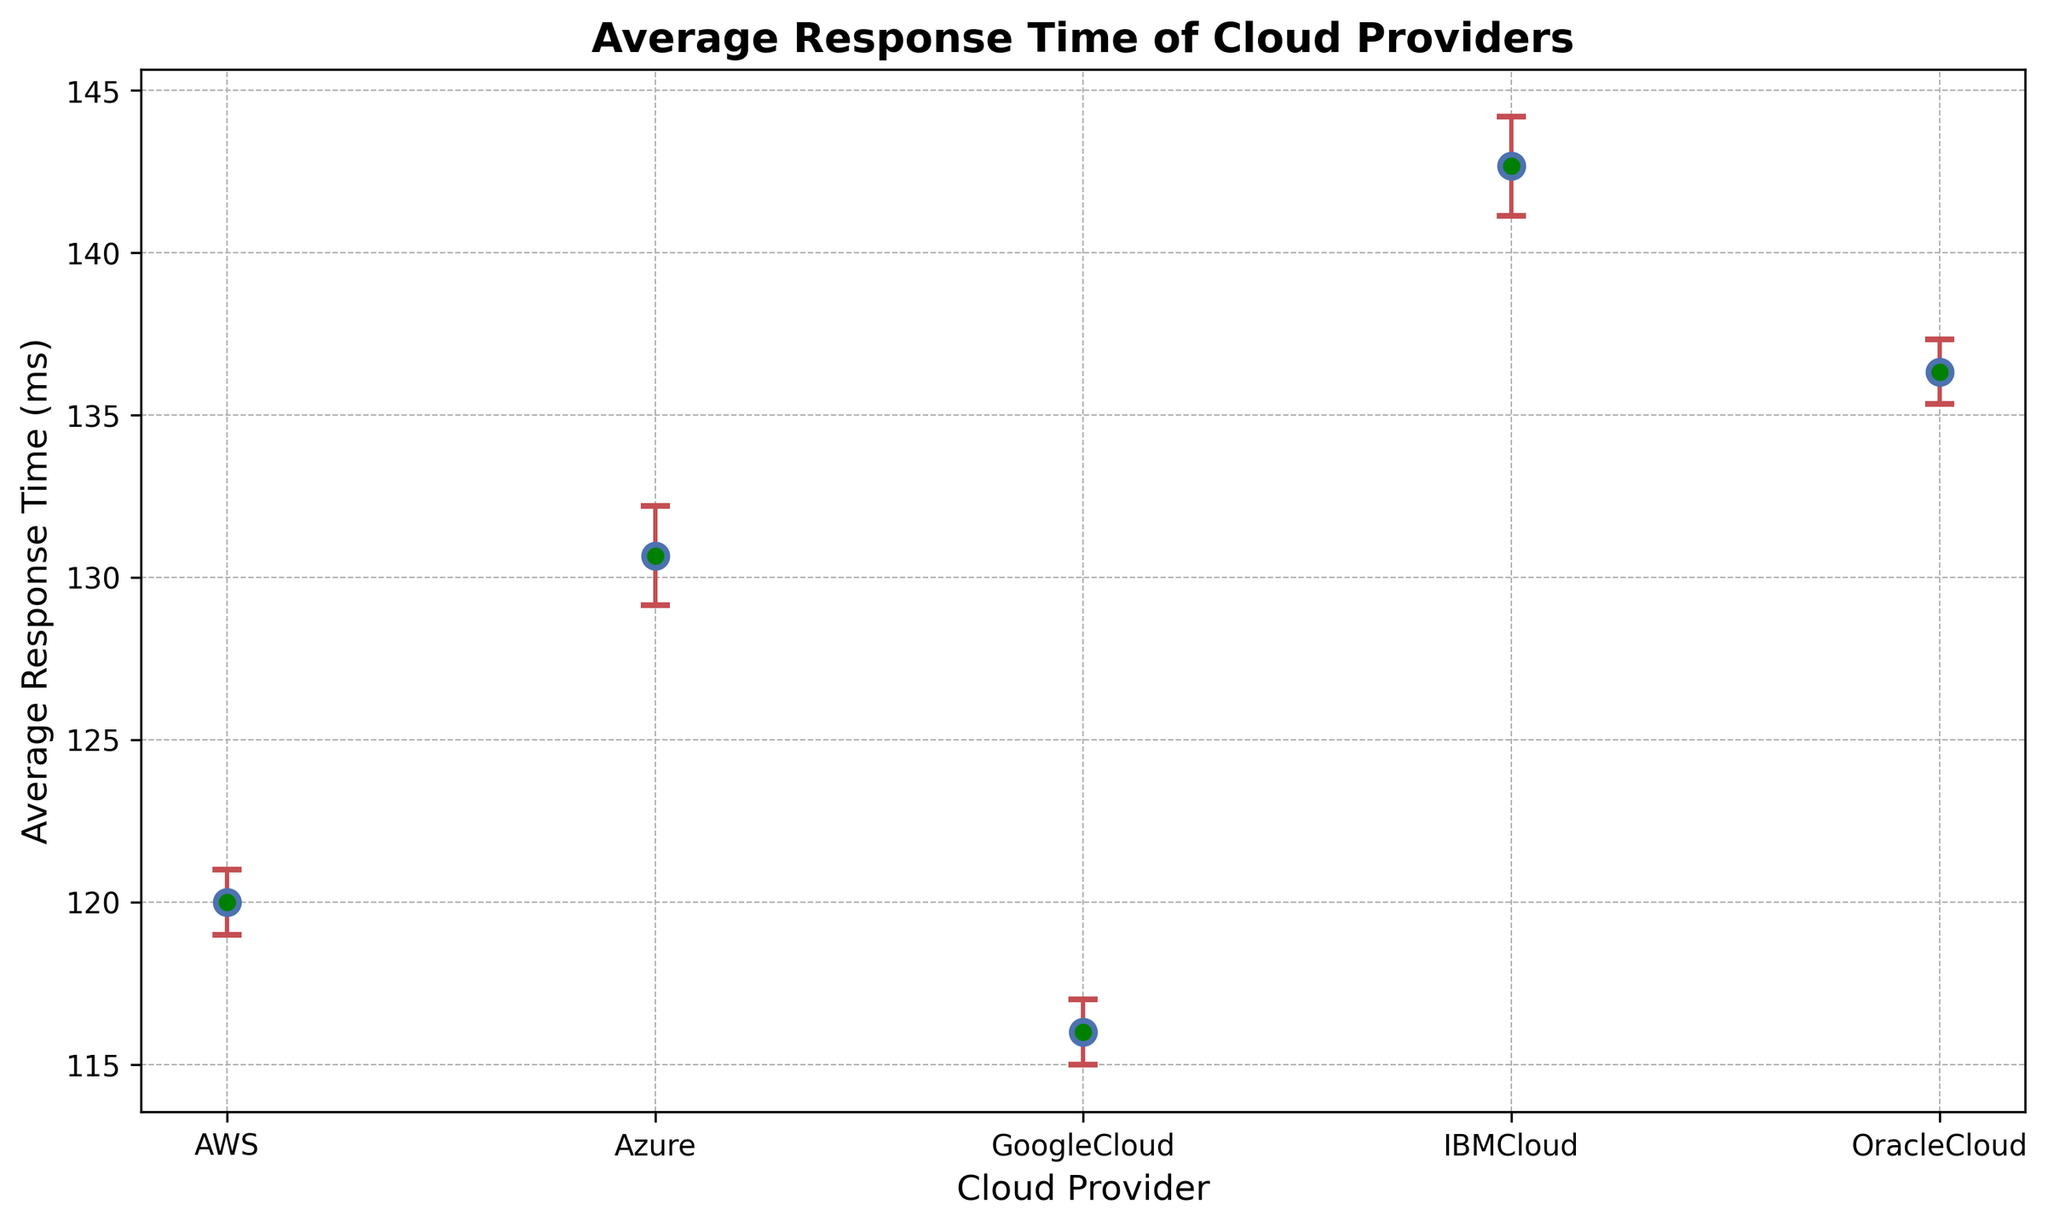What is the cloud provider with the highest average response time? By looking at the figure, you can see that the mean response time for each cloud provider is represented by a data point. The data point for IBMCloud is the highest on the y-axis, indicating the highest average response time.
Answer: IBMCloud Which cloud provider has the smallest average response time? By examining the plot, the data point for GoogleCloud is the lowest on the y-axis, indicating the smallest average response time.
Answer: GoogleCloud Which cloud providers' average response times overlap considering the error bars? By observing the figure, the error bars for AWS and GoogleCloud overlap, indicating that their response times might not be significantly different.
Answer: AWS and GoogleCloud Which provider has the largest variability in response time? To find the provider with the largest variability, look at the length of the error bars. IBMCloud's error bars are the longest, indicating the highest standard deviation.
Answer: IBMCloud What's the difference between the highest and lowest average response times among the cloud providers? IBMCloud has the highest average response time (highest data point) and GoogleCloud has the lowest (lowest data point). Subtracting GoogleCloud's average from IBMCloud's gives 143 - 116 = 27 ms.
Answer: 27 ms Which cloud provider has the smallest variability in their response times? By looking at the lengths of the error bars, GoogleCloud has the shortest error bars, indicating the smallest variability.
Answer: GoogleCloud Compare the average response time of OracleCloud to AWS. OracleCloud has a higher average response time data point compared to AWS. The difference can be observed visually as the OracleCloud point is above the AWS point on the y-axis.
Answer: OracleCloud is higher If we exclude IBMCloud due to its high error bars, which provider would have the next highest variability? Excluding IBMCloud, OracleCloud's error bars are the next longest, indicating higher variability.
Answer: OracleCloud Is the average response time of Azure greater than the average response time of AWS? By comparing the data points, the average response time of Azure is higher than that of AWS as Azure's point is above AWS's on the y-axis.
Answer: Yes How does the variability (standard deviation) of response times in Azure compare to OracleCloud? By observing the lengths of the error bars, OracleCloud's error bars are slightly longer than Azure's, indicating higher variability in OracleCloud.
Answer: OracleCloud has higher variability 